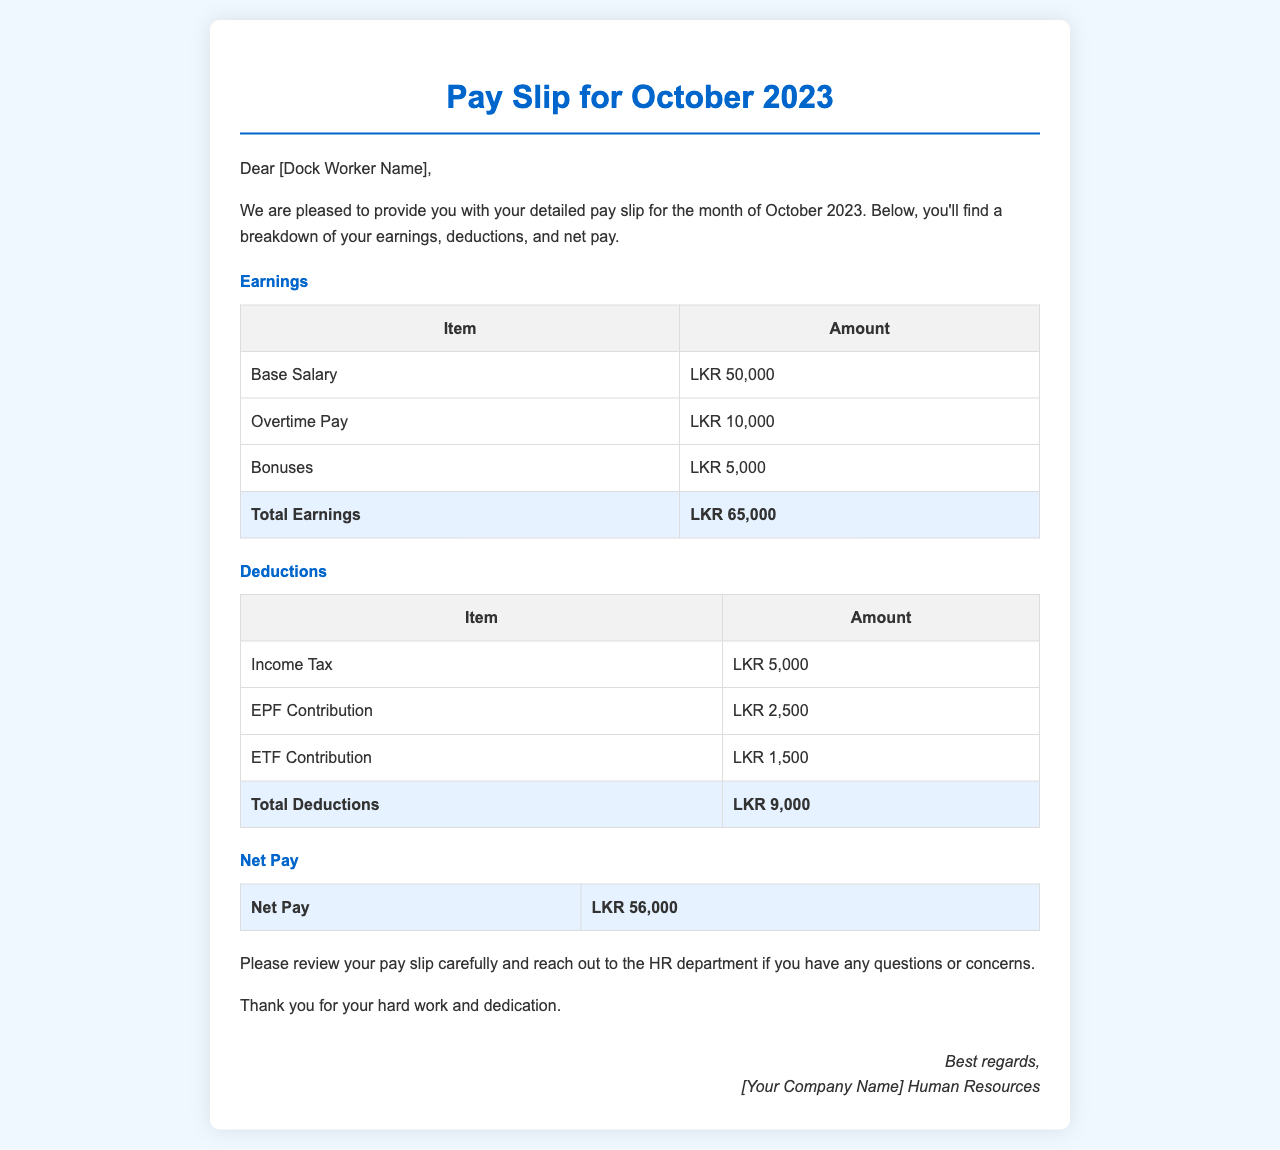What is the base salary? The base salary is listed in the earnings section of the document as LKR 50,000.
Answer: LKR 50,000 What is the total earnings amount? The total earnings is calculated by adding all earnings items, which totals to LKR 65,000.
Answer: LKR 65,000 What is the income tax deduction? The income tax deduction is explicitly mentioned in the deductions section as LKR 5,000.
Answer: LKR 5,000 What is the total deductions amount? The total deductions is the sum of all deductions, which equals LKR 9,000.
Answer: LKR 9,000 What is the net pay for October 2023? The net pay is calculated by subtracting total deductions from total earnings and is specified in the document as LKR 56,000.
Answer: LKR 56,000 What is the bonus amount listed? The bonus amount listed under earnings is LKR 5,000.
Answer: LKR 5,000 How much is the ETF contribution? The ETF contribution is noted in the deductions section as LKR 1,500.
Answer: LKR 1,500 What is the purpose of this document? The purpose of the document is to provide a detailed pay slip for the month of October 2023.
Answer: Pay slip Who should be contacted for questions or concerns? The HR department is mentioned as the contact for any questions or concerns regarding the pay slip.
Answer: HR department 